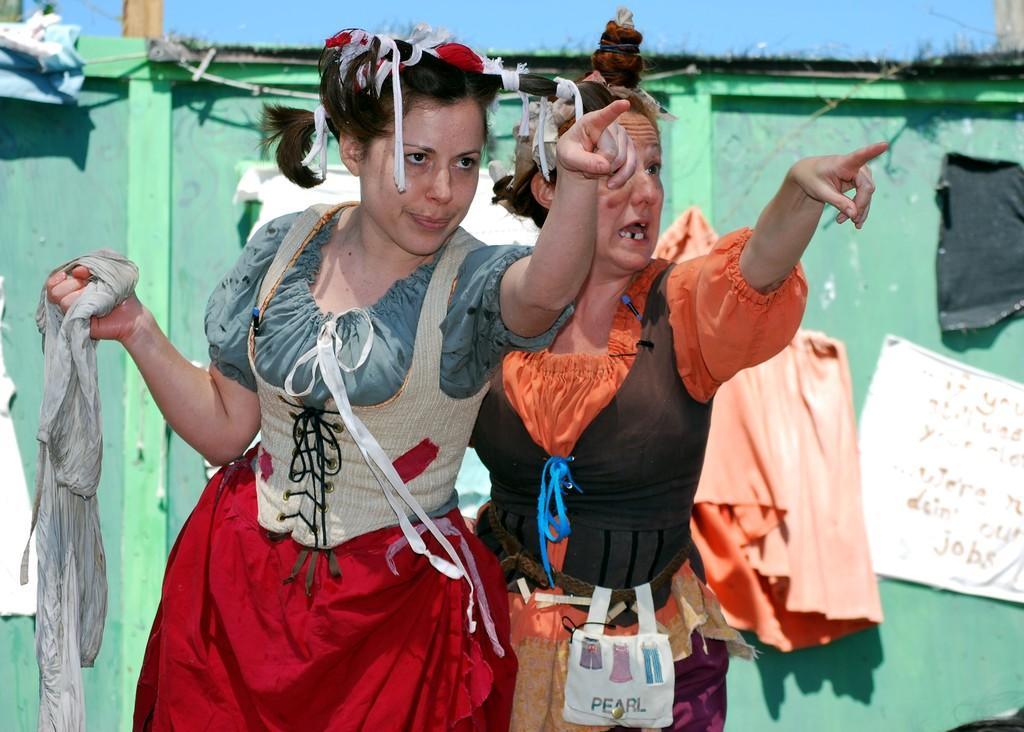Can you describe this image briefly? At the top we can see sky. This is a door and we can see papers over it. Here we can see two women standing and pointing towards a camera. She is holding a cloth in her hand. 